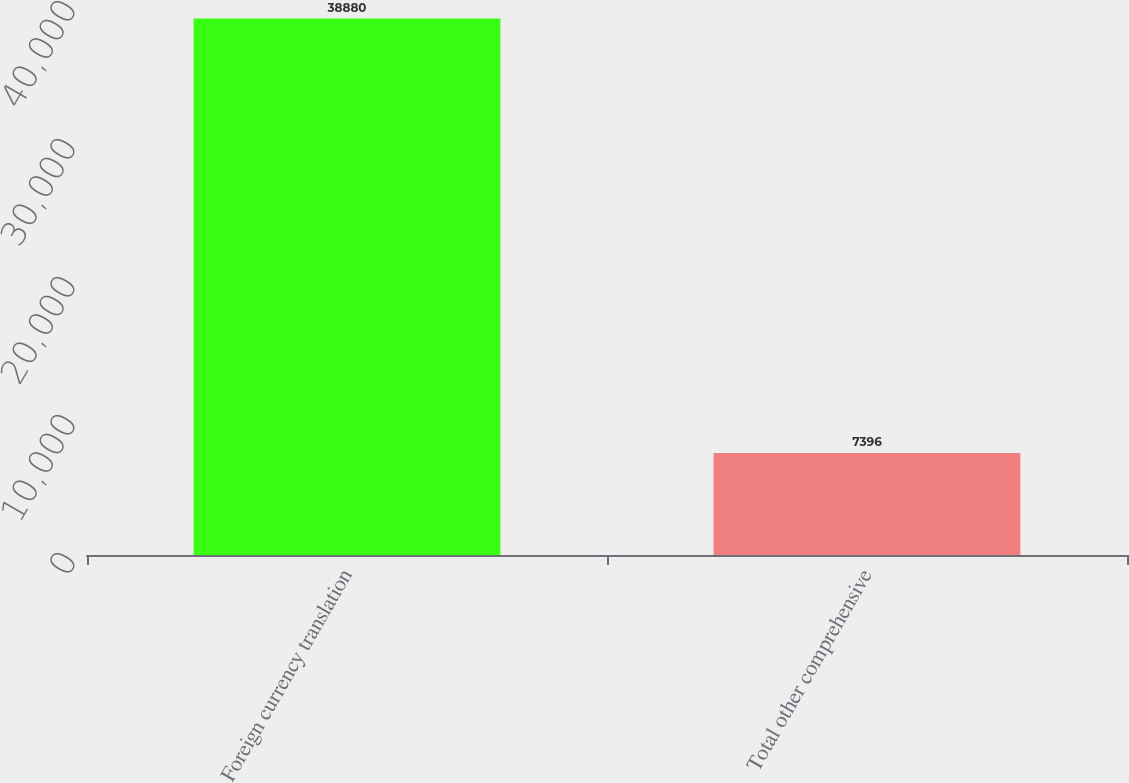Convert chart. <chart><loc_0><loc_0><loc_500><loc_500><bar_chart><fcel>Foreign currency translation<fcel>Total other comprehensive<nl><fcel>38880<fcel>7396<nl></chart> 